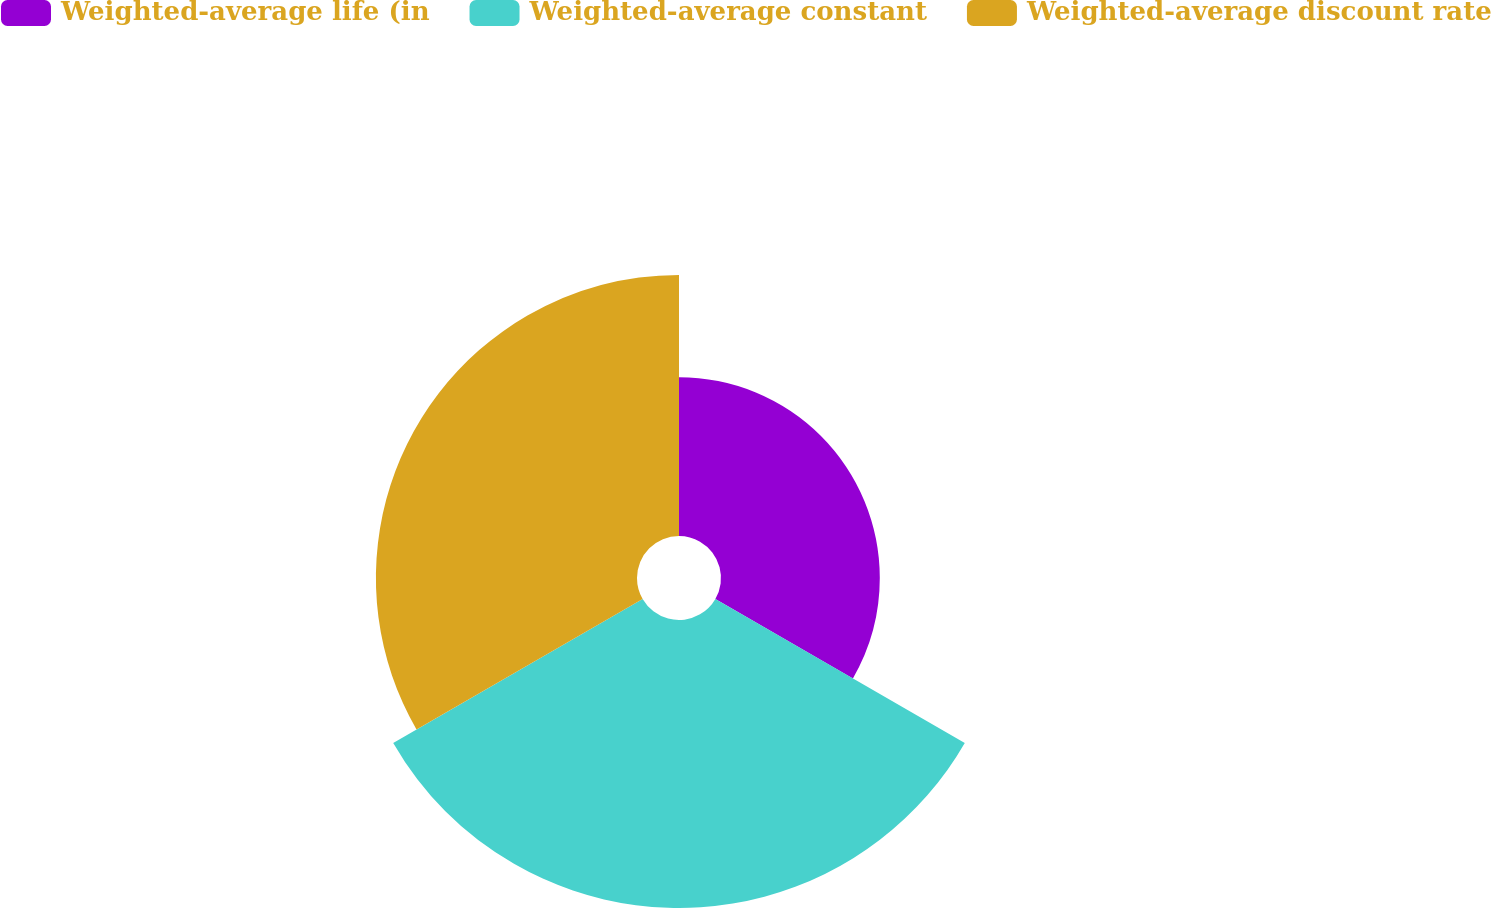<chart> <loc_0><loc_0><loc_500><loc_500><pie_chart><fcel>Weighted-average life (in<fcel>Weighted-average constant<fcel>Weighted-average discount rate<nl><fcel>22.43%<fcel>40.68%<fcel>36.88%<nl></chart> 